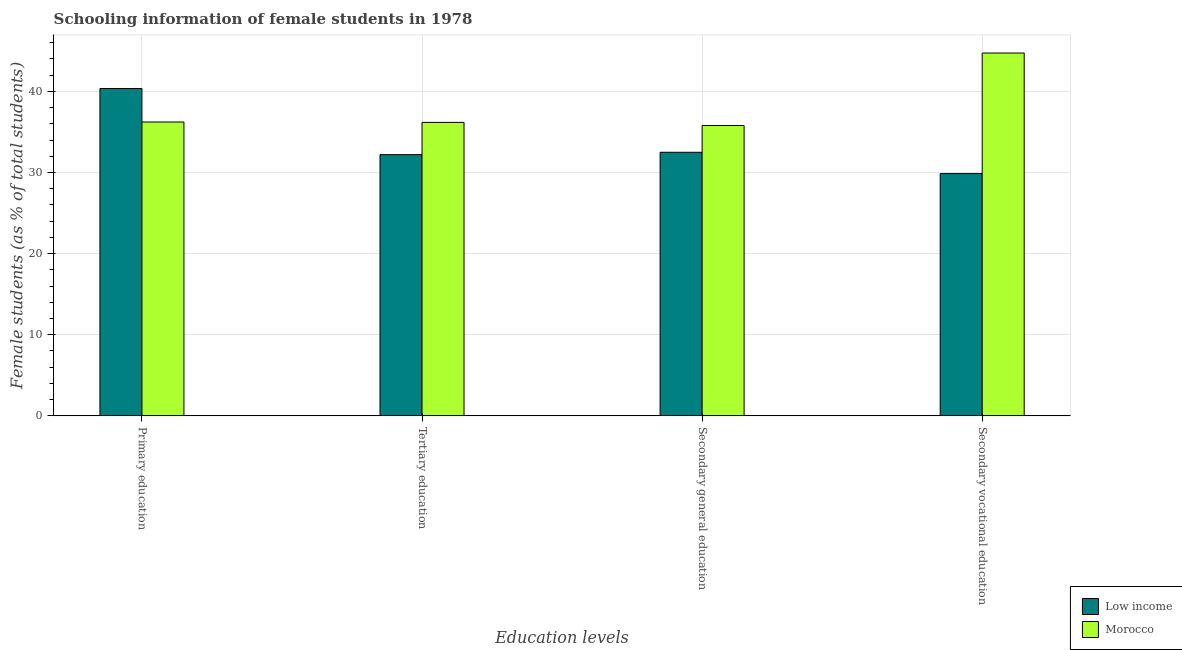How many different coloured bars are there?
Provide a succinct answer. 2. Are the number of bars on each tick of the X-axis equal?
Your answer should be compact. Yes. What is the label of the 2nd group of bars from the left?
Give a very brief answer. Tertiary education. What is the percentage of female students in primary education in Low income?
Your answer should be compact. 40.35. Across all countries, what is the maximum percentage of female students in primary education?
Your answer should be compact. 40.35. Across all countries, what is the minimum percentage of female students in tertiary education?
Your response must be concise. 32.2. In which country was the percentage of female students in tertiary education maximum?
Provide a succinct answer. Morocco. What is the total percentage of female students in primary education in the graph?
Keep it short and to the point. 76.58. What is the difference between the percentage of female students in secondary vocational education in Morocco and that in Low income?
Ensure brevity in your answer.  14.86. What is the difference between the percentage of female students in secondary education in Morocco and the percentage of female students in primary education in Low income?
Provide a succinct answer. -4.56. What is the average percentage of female students in tertiary education per country?
Provide a short and direct response. 34.19. What is the difference between the percentage of female students in primary education and percentage of female students in secondary education in Morocco?
Make the answer very short. 0.43. In how many countries, is the percentage of female students in secondary education greater than 10 %?
Offer a terse response. 2. What is the ratio of the percentage of female students in tertiary education in Morocco to that in Low income?
Ensure brevity in your answer.  1.12. What is the difference between the highest and the second highest percentage of female students in primary education?
Offer a terse response. 4.13. What is the difference between the highest and the lowest percentage of female students in secondary vocational education?
Offer a terse response. 14.86. What does the 1st bar from the left in Secondary vocational education represents?
Your answer should be very brief. Low income. Is it the case that in every country, the sum of the percentage of female students in primary education and percentage of female students in tertiary education is greater than the percentage of female students in secondary education?
Provide a succinct answer. Yes. How many bars are there?
Your answer should be very brief. 8. Are all the bars in the graph horizontal?
Make the answer very short. No. How many countries are there in the graph?
Provide a short and direct response. 2. What is the difference between two consecutive major ticks on the Y-axis?
Give a very brief answer. 10. Where does the legend appear in the graph?
Make the answer very short. Bottom right. How many legend labels are there?
Your answer should be very brief. 2. What is the title of the graph?
Your answer should be compact. Schooling information of female students in 1978. What is the label or title of the X-axis?
Your answer should be compact. Education levels. What is the label or title of the Y-axis?
Keep it short and to the point. Female students (as % of total students). What is the Female students (as % of total students) in Low income in Primary education?
Your answer should be compact. 40.35. What is the Female students (as % of total students) in Morocco in Primary education?
Give a very brief answer. 36.22. What is the Female students (as % of total students) of Low income in Tertiary education?
Your answer should be compact. 32.2. What is the Female students (as % of total students) in Morocco in Tertiary education?
Your answer should be compact. 36.18. What is the Female students (as % of total students) of Low income in Secondary general education?
Provide a short and direct response. 32.49. What is the Female students (as % of total students) in Morocco in Secondary general education?
Your response must be concise. 35.79. What is the Female students (as % of total students) of Low income in Secondary vocational education?
Provide a short and direct response. 29.87. What is the Female students (as % of total students) in Morocco in Secondary vocational education?
Provide a succinct answer. 44.73. Across all Education levels, what is the maximum Female students (as % of total students) of Low income?
Make the answer very short. 40.35. Across all Education levels, what is the maximum Female students (as % of total students) of Morocco?
Give a very brief answer. 44.73. Across all Education levels, what is the minimum Female students (as % of total students) in Low income?
Offer a terse response. 29.87. Across all Education levels, what is the minimum Female students (as % of total students) of Morocco?
Offer a terse response. 35.79. What is the total Female students (as % of total students) in Low income in the graph?
Your response must be concise. 134.92. What is the total Female students (as % of total students) of Morocco in the graph?
Ensure brevity in your answer.  152.93. What is the difference between the Female students (as % of total students) in Low income in Primary education and that in Tertiary education?
Provide a short and direct response. 8.15. What is the difference between the Female students (as % of total students) in Morocco in Primary education and that in Tertiary education?
Ensure brevity in your answer.  0.04. What is the difference between the Female students (as % of total students) of Low income in Primary education and that in Secondary general education?
Your answer should be very brief. 7.86. What is the difference between the Female students (as % of total students) in Morocco in Primary education and that in Secondary general education?
Offer a very short reply. 0.43. What is the difference between the Female students (as % of total students) in Low income in Primary education and that in Secondary vocational education?
Your answer should be very brief. 10.48. What is the difference between the Female students (as % of total students) in Morocco in Primary education and that in Secondary vocational education?
Ensure brevity in your answer.  -8.51. What is the difference between the Female students (as % of total students) in Low income in Tertiary education and that in Secondary general education?
Keep it short and to the point. -0.29. What is the difference between the Female students (as % of total students) in Morocco in Tertiary education and that in Secondary general education?
Provide a succinct answer. 0.39. What is the difference between the Female students (as % of total students) of Low income in Tertiary education and that in Secondary vocational education?
Keep it short and to the point. 2.33. What is the difference between the Female students (as % of total students) in Morocco in Tertiary education and that in Secondary vocational education?
Keep it short and to the point. -8.55. What is the difference between the Female students (as % of total students) of Low income in Secondary general education and that in Secondary vocational education?
Offer a very short reply. 2.62. What is the difference between the Female students (as % of total students) of Morocco in Secondary general education and that in Secondary vocational education?
Make the answer very short. -8.94. What is the difference between the Female students (as % of total students) of Low income in Primary education and the Female students (as % of total students) of Morocco in Tertiary education?
Provide a short and direct response. 4.18. What is the difference between the Female students (as % of total students) of Low income in Primary education and the Female students (as % of total students) of Morocco in Secondary general education?
Ensure brevity in your answer.  4.56. What is the difference between the Female students (as % of total students) in Low income in Primary education and the Female students (as % of total students) in Morocco in Secondary vocational education?
Offer a very short reply. -4.38. What is the difference between the Female students (as % of total students) in Low income in Tertiary education and the Female students (as % of total students) in Morocco in Secondary general education?
Offer a terse response. -3.59. What is the difference between the Female students (as % of total students) in Low income in Tertiary education and the Female students (as % of total students) in Morocco in Secondary vocational education?
Ensure brevity in your answer.  -12.53. What is the difference between the Female students (as % of total students) in Low income in Secondary general education and the Female students (as % of total students) in Morocco in Secondary vocational education?
Your answer should be very brief. -12.24. What is the average Female students (as % of total students) in Low income per Education levels?
Your response must be concise. 33.73. What is the average Female students (as % of total students) in Morocco per Education levels?
Offer a terse response. 38.23. What is the difference between the Female students (as % of total students) in Low income and Female students (as % of total students) in Morocco in Primary education?
Your answer should be very brief. 4.13. What is the difference between the Female students (as % of total students) of Low income and Female students (as % of total students) of Morocco in Tertiary education?
Provide a succinct answer. -3.98. What is the difference between the Female students (as % of total students) in Low income and Female students (as % of total students) in Morocco in Secondary general education?
Your response must be concise. -3.3. What is the difference between the Female students (as % of total students) of Low income and Female students (as % of total students) of Morocco in Secondary vocational education?
Make the answer very short. -14.86. What is the ratio of the Female students (as % of total students) in Low income in Primary education to that in Tertiary education?
Give a very brief answer. 1.25. What is the ratio of the Female students (as % of total students) in Morocco in Primary education to that in Tertiary education?
Give a very brief answer. 1. What is the ratio of the Female students (as % of total students) of Low income in Primary education to that in Secondary general education?
Make the answer very short. 1.24. What is the ratio of the Female students (as % of total students) of Morocco in Primary education to that in Secondary general education?
Your answer should be compact. 1.01. What is the ratio of the Female students (as % of total students) in Low income in Primary education to that in Secondary vocational education?
Provide a succinct answer. 1.35. What is the ratio of the Female students (as % of total students) in Morocco in Primary education to that in Secondary vocational education?
Provide a short and direct response. 0.81. What is the ratio of the Female students (as % of total students) of Low income in Tertiary education to that in Secondary general education?
Offer a very short reply. 0.99. What is the ratio of the Female students (as % of total students) in Morocco in Tertiary education to that in Secondary general education?
Make the answer very short. 1.01. What is the ratio of the Female students (as % of total students) of Low income in Tertiary education to that in Secondary vocational education?
Provide a succinct answer. 1.08. What is the ratio of the Female students (as % of total students) in Morocco in Tertiary education to that in Secondary vocational education?
Provide a short and direct response. 0.81. What is the ratio of the Female students (as % of total students) of Low income in Secondary general education to that in Secondary vocational education?
Provide a succinct answer. 1.09. What is the ratio of the Female students (as % of total students) of Morocco in Secondary general education to that in Secondary vocational education?
Offer a terse response. 0.8. What is the difference between the highest and the second highest Female students (as % of total students) in Low income?
Provide a short and direct response. 7.86. What is the difference between the highest and the second highest Female students (as % of total students) of Morocco?
Offer a terse response. 8.51. What is the difference between the highest and the lowest Female students (as % of total students) of Low income?
Ensure brevity in your answer.  10.48. What is the difference between the highest and the lowest Female students (as % of total students) of Morocco?
Your answer should be very brief. 8.94. 